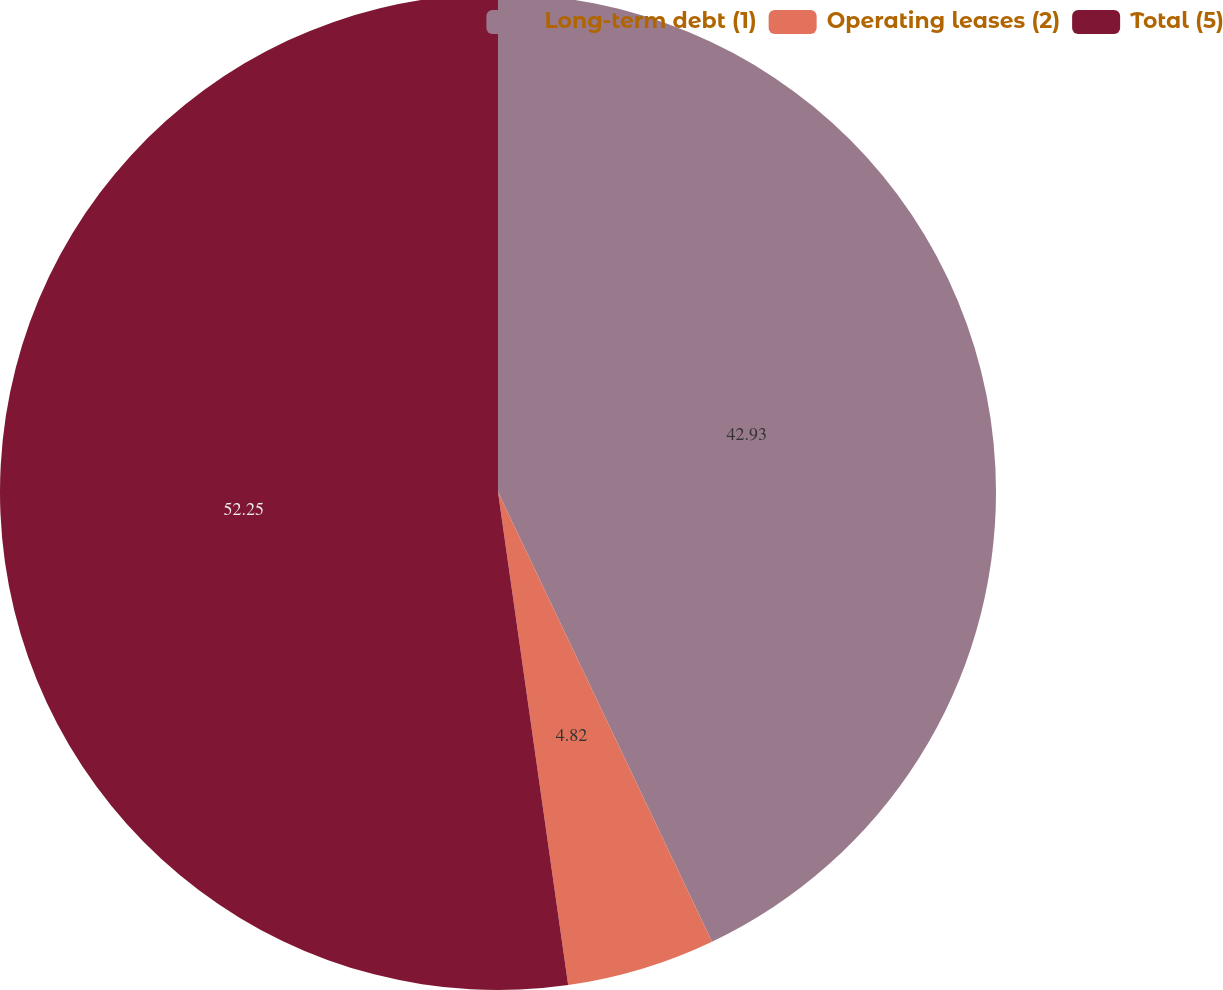<chart> <loc_0><loc_0><loc_500><loc_500><pie_chart><fcel>Long-term debt (1)<fcel>Operating leases (2)<fcel>Total (5)<nl><fcel>42.93%<fcel>4.82%<fcel>52.25%<nl></chart> 